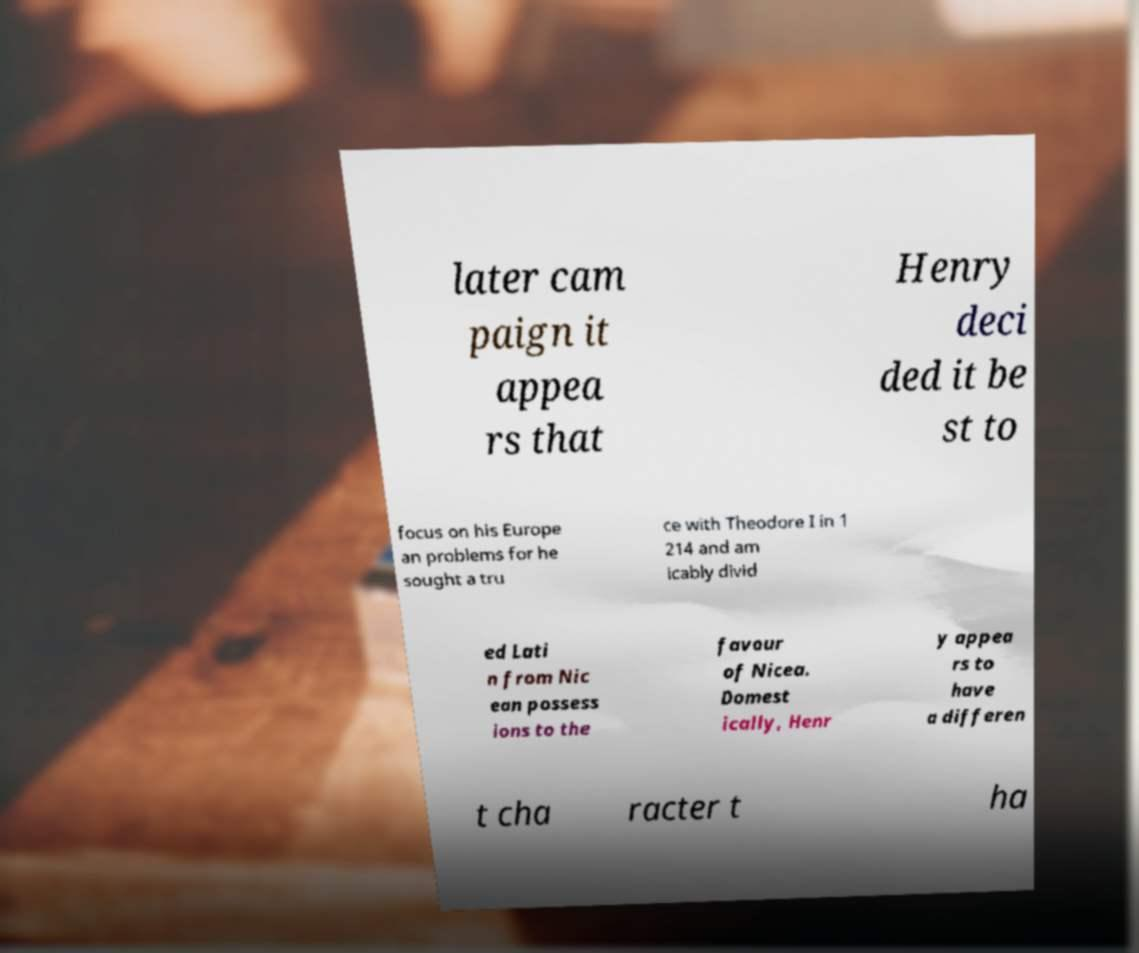Can you accurately transcribe the text from the provided image for me? later cam paign it appea rs that Henry deci ded it be st to focus on his Europe an problems for he sought a tru ce with Theodore I in 1 214 and am icably divid ed Lati n from Nic ean possess ions to the favour of Nicea. Domest ically, Henr y appea rs to have a differen t cha racter t ha 